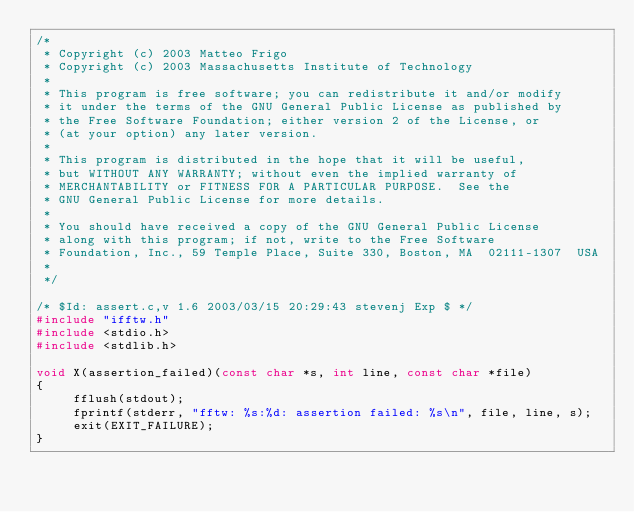<code> <loc_0><loc_0><loc_500><loc_500><_C_>/*
 * Copyright (c) 2003 Matteo Frigo
 * Copyright (c) 2003 Massachusetts Institute of Technology
 *
 * This program is free software; you can redistribute it and/or modify
 * it under the terms of the GNU General Public License as published by
 * the Free Software Foundation; either version 2 of the License, or
 * (at your option) any later version.
 *
 * This program is distributed in the hope that it will be useful,
 * but WITHOUT ANY WARRANTY; without even the implied warranty of
 * MERCHANTABILITY or FITNESS FOR A PARTICULAR PURPOSE.  See the
 * GNU General Public License for more details.
 *
 * You should have received a copy of the GNU General Public License
 * along with this program; if not, write to the Free Software
 * Foundation, Inc., 59 Temple Place, Suite 330, Boston, MA  02111-1307  USA
 *
 */

/* $Id: assert.c,v 1.6 2003/03/15 20:29:43 stevenj Exp $ */
#include "ifftw.h"
#include <stdio.h>
#include <stdlib.h>

void X(assertion_failed)(const char *s, int line, const char *file)
{
     fflush(stdout);
     fprintf(stderr, "fftw: %s:%d: assertion failed: %s\n", file, line, s);
     exit(EXIT_FAILURE);
}
</code> 